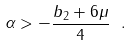Convert formula to latex. <formula><loc_0><loc_0><loc_500><loc_500>\alpha > - \frac { b _ { 2 } + 6 \mu } { 4 } \ .</formula> 